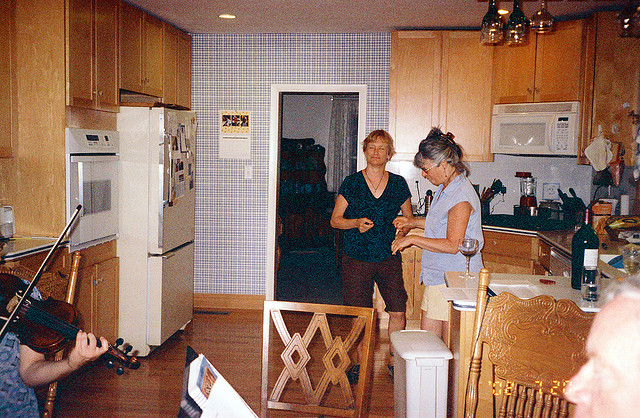What instrument is being played? The person is playing a violin, a stringed instrument known for its rich and emotive sound, often used in a wide range of musical genres from classical to folk. 